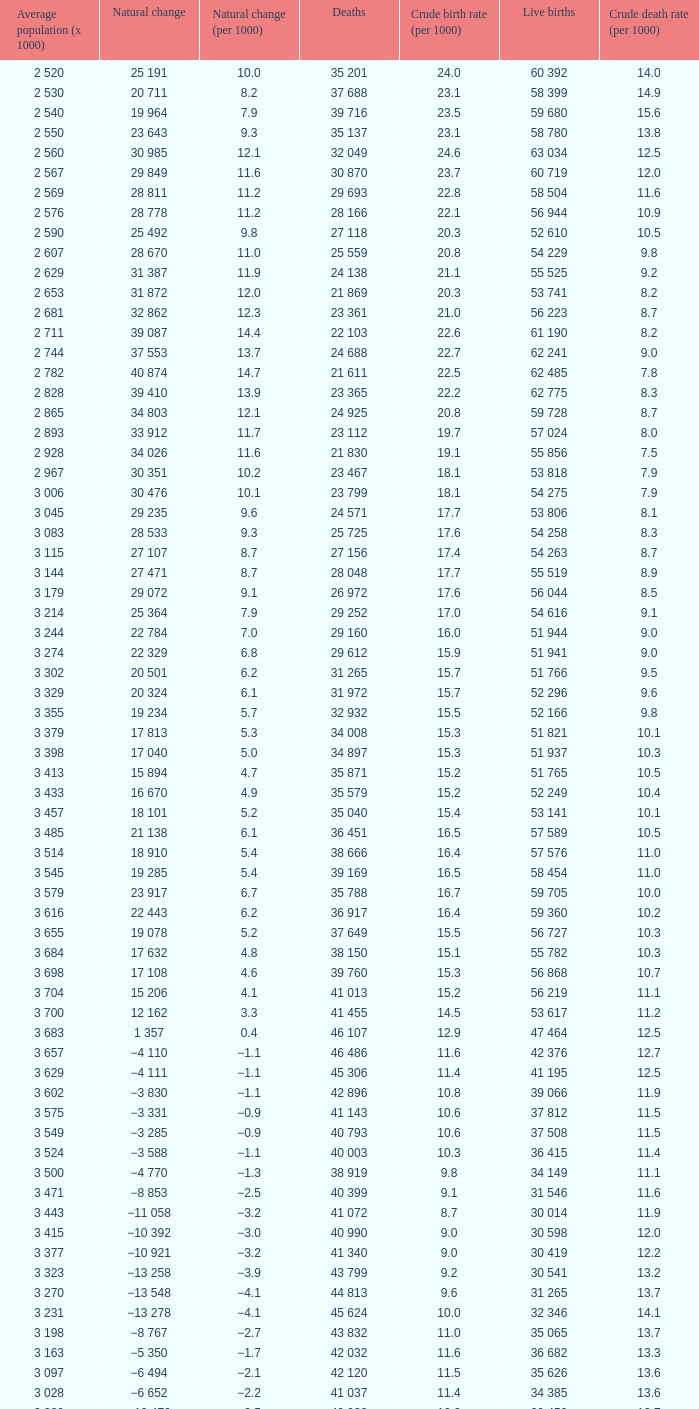Which Natural change has a Crude death rate (per 1000) larger than 9, and Deaths of 40 399? −8 853. 